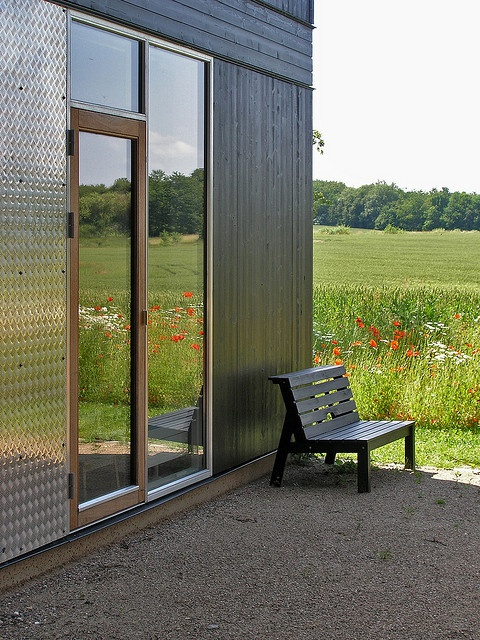Describe the objects in this image and their specific colors. I can see a bench in darkgray, black, gray, darkgreen, and lavender tones in this image. 